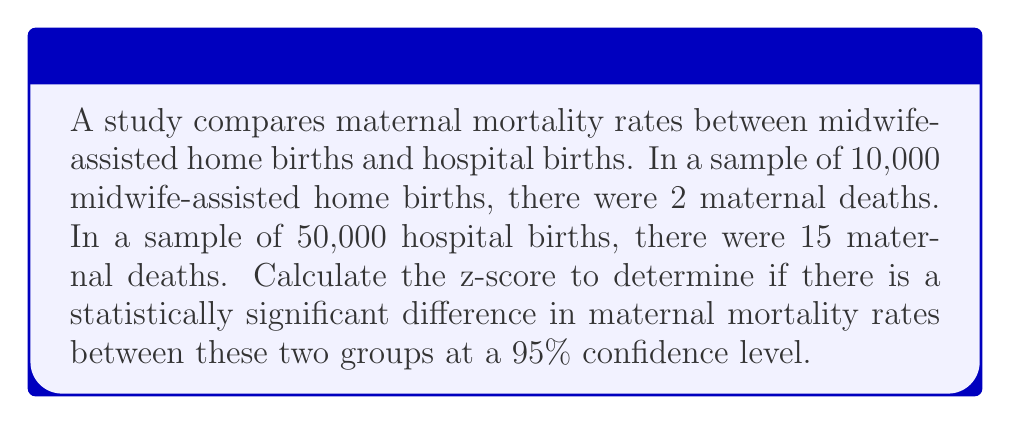Give your solution to this math problem. To calculate the statistical significance, we'll use a z-test for the difference between two proportions.

Step 1: Calculate the proportions for each group
Midwife-assisted: $p_1 = \frac{2}{10,000} = 0.0002$
Hospital: $p_2 = \frac{15}{50,000} = 0.0003$

Step 2: Calculate the pooled proportion
$p = \frac{n_1p_1 + n_2p_2}{n_1 + n_2} = \frac{10,000(0.0002) + 50,000(0.0003)}{10,000 + 50,000} = 0.00028333$

Step 3: Calculate the standard error
$SE = \sqrt{p(1-p)(\frac{1}{n_1} + \frac{1}{n_2})}$
$SE = \sqrt{0.00028333(1-0.00028333)(\frac{1}{10,000} + \frac{1}{50,000})} = 0.00019245$

Step 4: Calculate the z-score
$z = \frac{p_1 - p_2}{SE} = \frac{0.0002 - 0.0003}{0.00019245} = -0.5196$

Step 5: Determine significance
At a 95% confidence level, the critical z-value is ±1.96. Since |-0.5196| < 1.96, the difference is not statistically significant.
Answer: $z = -0.5196$; not statistically significant 